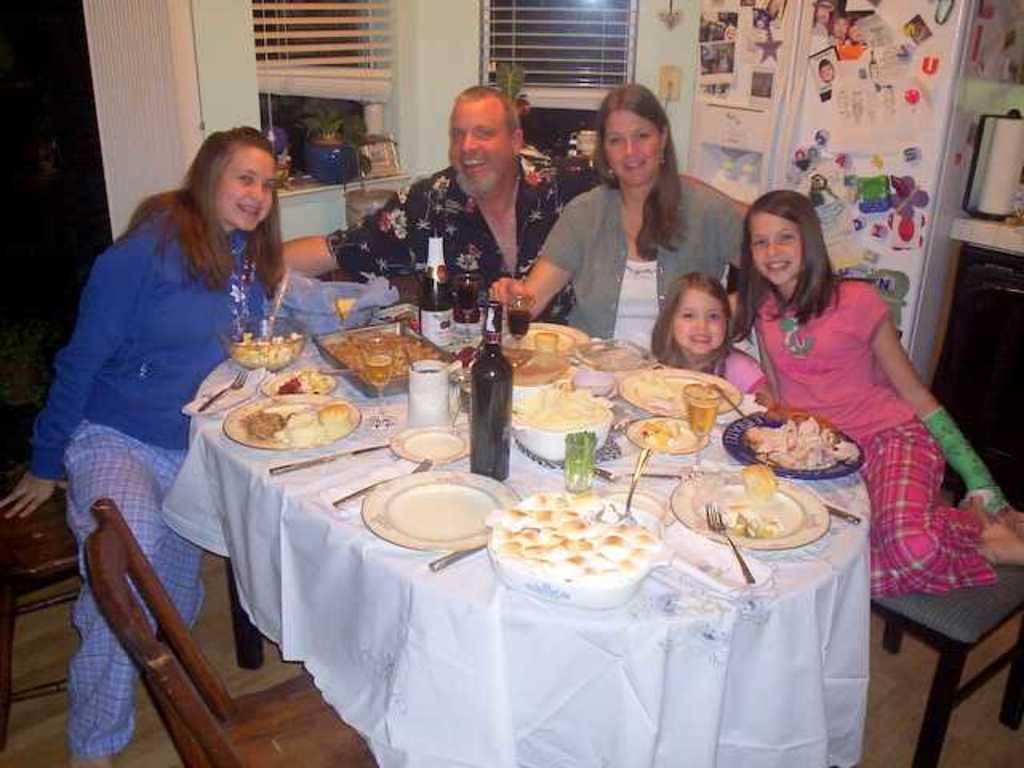Please provide a concise description of this image. In the image there is a man,two women and two kids sat on chairs around dining table with food,plates,spoons,wine bottles and on right side corner there is refrigerator and there are two windows on back side of the man. 